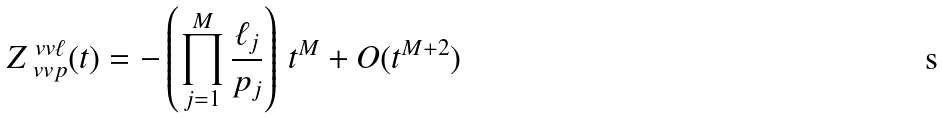<formula> <loc_0><loc_0><loc_500><loc_500>Z _ { \ v v { p } } ^ { \ v v { \ell } } ( t ) = - \left ( \prod _ { j = 1 } ^ { M } \frac { \ell _ { j } } { p _ { j } } \right ) \, t ^ { M } + O ( t ^ { M + 2 } )</formula> 